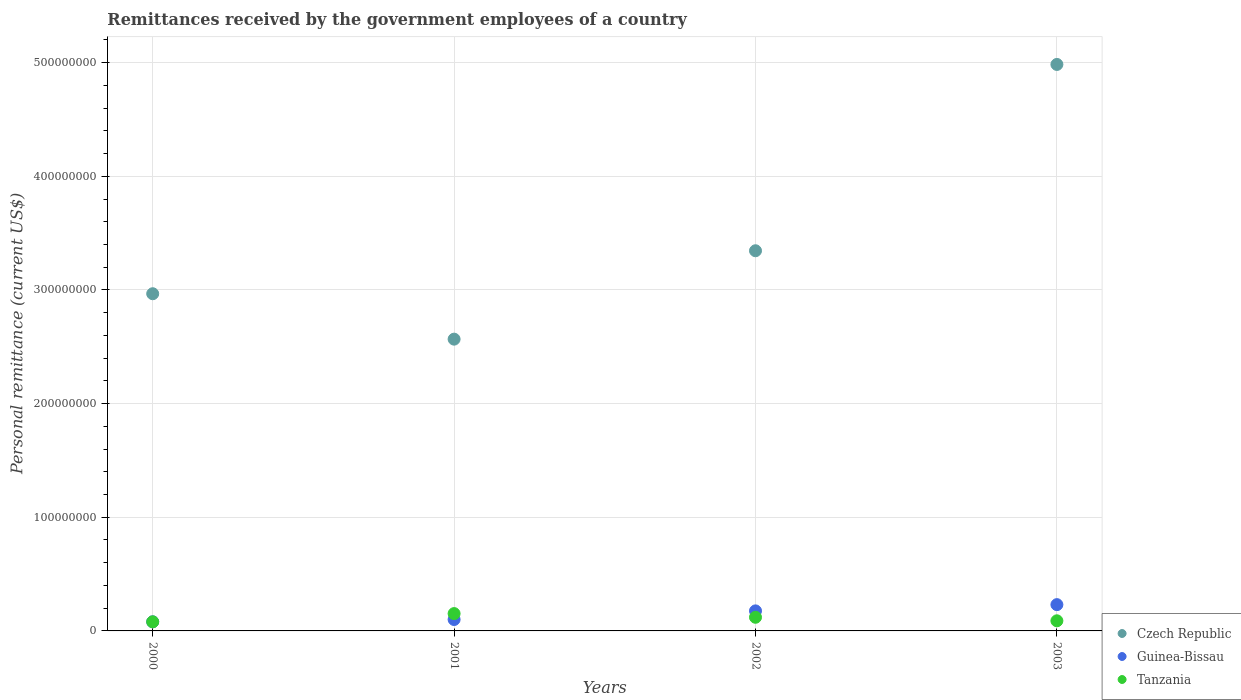How many different coloured dotlines are there?
Make the answer very short. 3. Is the number of dotlines equal to the number of legend labels?
Ensure brevity in your answer.  Yes. What is the remittances received by the government employees in Guinea-Bissau in 2003?
Your answer should be compact. 2.31e+07. Across all years, what is the maximum remittances received by the government employees in Guinea-Bissau?
Your answer should be compact. 2.31e+07. Across all years, what is the minimum remittances received by the government employees in Czech Republic?
Ensure brevity in your answer.  2.57e+08. What is the total remittances received by the government employees in Czech Republic in the graph?
Offer a terse response. 1.39e+09. What is the difference between the remittances received by the government employees in Czech Republic in 2000 and that in 2003?
Your response must be concise. -2.02e+08. What is the difference between the remittances received by the government employees in Czech Republic in 2003 and the remittances received by the government employees in Tanzania in 2001?
Provide a short and direct response. 4.83e+08. What is the average remittances received by the government employees in Czech Republic per year?
Your response must be concise. 3.47e+08. In the year 2003, what is the difference between the remittances received by the government employees in Tanzania and remittances received by the government employees in Czech Republic?
Your answer should be very brief. -4.90e+08. What is the ratio of the remittances received by the government employees in Czech Republic in 2000 to that in 2002?
Provide a short and direct response. 0.89. Is the remittances received by the government employees in Tanzania in 2000 less than that in 2001?
Give a very brief answer. Yes. What is the difference between the highest and the second highest remittances received by the government employees in Tanzania?
Provide a succinct answer. 3.25e+06. What is the difference between the highest and the lowest remittances received by the government employees in Tanzania?
Ensure brevity in your answer.  7.25e+06. In how many years, is the remittances received by the government employees in Guinea-Bissau greater than the average remittances received by the government employees in Guinea-Bissau taken over all years?
Offer a very short reply. 2. Is it the case that in every year, the sum of the remittances received by the government employees in Tanzania and remittances received by the government employees in Czech Republic  is greater than the remittances received by the government employees in Guinea-Bissau?
Provide a short and direct response. Yes. How many years are there in the graph?
Make the answer very short. 4. Are the values on the major ticks of Y-axis written in scientific E-notation?
Make the answer very short. No. What is the title of the graph?
Offer a very short reply. Remittances received by the government employees of a country. What is the label or title of the X-axis?
Your answer should be very brief. Years. What is the label or title of the Y-axis?
Your answer should be very brief. Personal remittance (current US$). What is the Personal remittance (current US$) in Czech Republic in 2000?
Give a very brief answer. 2.97e+08. What is the Personal remittance (current US$) in Guinea-Bissau in 2000?
Provide a short and direct response. 8.02e+06. What is the Personal remittance (current US$) in Tanzania in 2000?
Ensure brevity in your answer.  8.00e+06. What is the Personal remittance (current US$) of Czech Republic in 2001?
Your answer should be compact. 2.57e+08. What is the Personal remittance (current US$) in Guinea-Bissau in 2001?
Offer a terse response. 1.00e+07. What is the Personal remittance (current US$) in Tanzania in 2001?
Offer a very short reply. 1.53e+07. What is the Personal remittance (current US$) of Czech Republic in 2002?
Keep it short and to the point. 3.34e+08. What is the Personal remittance (current US$) of Guinea-Bissau in 2002?
Give a very brief answer. 1.76e+07. What is the Personal remittance (current US$) in Czech Republic in 2003?
Give a very brief answer. 4.98e+08. What is the Personal remittance (current US$) of Guinea-Bissau in 2003?
Provide a short and direct response. 2.31e+07. What is the Personal remittance (current US$) in Tanzania in 2003?
Your answer should be compact. 8.90e+06. Across all years, what is the maximum Personal remittance (current US$) of Czech Republic?
Your response must be concise. 4.98e+08. Across all years, what is the maximum Personal remittance (current US$) of Guinea-Bissau?
Your response must be concise. 2.31e+07. Across all years, what is the maximum Personal remittance (current US$) of Tanzania?
Offer a terse response. 1.53e+07. Across all years, what is the minimum Personal remittance (current US$) in Czech Republic?
Offer a terse response. 2.57e+08. Across all years, what is the minimum Personal remittance (current US$) in Guinea-Bissau?
Provide a short and direct response. 8.02e+06. Across all years, what is the minimum Personal remittance (current US$) of Tanzania?
Your answer should be compact. 8.00e+06. What is the total Personal remittance (current US$) in Czech Republic in the graph?
Give a very brief answer. 1.39e+09. What is the total Personal remittance (current US$) of Guinea-Bissau in the graph?
Offer a very short reply. 5.88e+07. What is the total Personal remittance (current US$) in Tanzania in the graph?
Make the answer very short. 4.42e+07. What is the difference between the Personal remittance (current US$) in Czech Republic in 2000 and that in 2001?
Provide a succinct answer. 4.00e+07. What is the difference between the Personal remittance (current US$) of Guinea-Bissau in 2000 and that in 2001?
Ensure brevity in your answer.  -2.01e+06. What is the difference between the Personal remittance (current US$) of Tanzania in 2000 and that in 2001?
Your answer should be very brief. -7.25e+06. What is the difference between the Personal remittance (current US$) of Czech Republic in 2000 and that in 2002?
Make the answer very short. -3.78e+07. What is the difference between the Personal remittance (current US$) in Guinea-Bissau in 2000 and that in 2002?
Keep it short and to the point. -9.61e+06. What is the difference between the Personal remittance (current US$) in Tanzania in 2000 and that in 2002?
Provide a short and direct response. -4.00e+06. What is the difference between the Personal remittance (current US$) of Czech Republic in 2000 and that in 2003?
Give a very brief answer. -2.02e+08. What is the difference between the Personal remittance (current US$) in Guinea-Bissau in 2000 and that in 2003?
Provide a short and direct response. -1.51e+07. What is the difference between the Personal remittance (current US$) in Tanzania in 2000 and that in 2003?
Provide a succinct answer. -9.00e+05. What is the difference between the Personal remittance (current US$) in Czech Republic in 2001 and that in 2002?
Provide a short and direct response. -7.78e+07. What is the difference between the Personal remittance (current US$) of Guinea-Bissau in 2001 and that in 2002?
Make the answer very short. -7.60e+06. What is the difference between the Personal remittance (current US$) of Tanzania in 2001 and that in 2002?
Your response must be concise. 3.25e+06. What is the difference between the Personal remittance (current US$) in Czech Republic in 2001 and that in 2003?
Make the answer very short. -2.42e+08. What is the difference between the Personal remittance (current US$) in Guinea-Bissau in 2001 and that in 2003?
Keep it short and to the point. -1.31e+07. What is the difference between the Personal remittance (current US$) in Tanzania in 2001 and that in 2003?
Keep it short and to the point. 6.35e+06. What is the difference between the Personal remittance (current US$) in Czech Republic in 2002 and that in 2003?
Offer a very short reply. -1.64e+08. What is the difference between the Personal remittance (current US$) in Guinea-Bissau in 2002 and that in 2003?
Offer a terse response. -5.49e+06. What is the difference between the Personal remittance (current US$) in Tanzania in 2002 and that in 2003?
Your answer should be compact. 3.10e+06. What is the difference between the Personal remittance (current US$) of Czech Republic in 2000 and the Personal remittance (current US$) of Guinea-Bissau in 2001?
Your answer should be compact. 2.87e+08. What is the difference between the Personal remittance (current US$) in Czech Republic in 2000 and the Personal remittance (current US$) in Tanzania in 2001?
Make the answer very short. 2.81e+08. What is the difference between the Personal remittance (current US$) in Guinea-Bissau in 2000 and the Personal remittance (current US$) in Tanzania in 2001?
Give a very brief answer. -7.23e+06. What is the difference between the Personal remittance (current US$) of Czech Republic in 2000 and the Personal remittance (current US$) of Guinea-Bissau in 2002?
Your response must be concise. 2.79e+08. What is the difference between the Personal remittance (current US$) of Czech Republic in 2000 and the Personal remittance (current US$) of Tanzania in 2002?
Offer a very short reply. 2.85e+08. What is the difference between the Personal remittance (current US$) in Guinea-Bissau in 2000 and the Personal remittance (current US$) in Tanzania in 2002?
Your answer should be compact. -3.98e+06. What is the difference between the Personal remittance (current US$) of Czech Republic in 2000 and the Personal remittance (current US$) of Guinea-Bissau in 2003?
Provide a short and direct response. 2.74e+08. What is the difference between the Personal remittance (current US$) of Czech Republic in 2000 and the Personal remittance (current US$) of Tanzania in 2003?
Offer a very short reply. 2.88e+08. What is the difference between the Personal remittance (current US$) in Guinea-Bissau in 2000 and the Personal remittance (current US$) in Tanzania in 2003?
Offer a very short reply. -8.79e+05. What is the difference between the Personal remittance (current US$) in Czech Republic in 2001 and the Personal remittance (current US$) in Guinea-Bissau in 2002?
Provide a short and direct response. 2.39e+08. What is the difference between the Personal remittance (current US$) of Czech Republic in 2001 and the Personal remittance (current US$) of Tanzania in 2002?
Make the answer very short. 2.45e+08. What is the difference between the Personal remittance (current US$) of Guinea-Bissau in 2001 and the Personal remittance (current US$) of Tanzania in 2002?
Provide a succinct answer. -1.97e+06. What is the difference between the Personal remittance (current US$) of Czech Republic in 2001 and the Personal remittance (current US$) of Guinea-Bissau in 2003?
Provide a succinct answer. 2.34e+08. What is the difference between the Personal remittance (current US$) in Czech Republic in 2001 and the Personal remittance (current US$) in Tanzania in 2003?
Ensure brevity in your answer.  2.48e+08. What is the difference between the Personal remittance (current US$) of Guinea-Bissau in 2001 and the Personal remittance (current US$) of Tanzania in 2003?
Provide a short and direct response. 1.13e+06. What is the difference between the Personal remittance (current US$) in Czech Republic in 2002 and the Personal remittance (current US$) in Guinea-Bissau in 2003?
Make the answer very short. 3.11e+08. What is the difference between the Personal remittance (current US$) in Czech Republic in 2002 and the Personal remittance (current US$) in Tanzania in 2003?
Your answer should be very brief. 3.26e+08. What is the difference between the Personal remittance (current US$) in Guinea-Bissau in 2002 and the Personal remittance (current US$) in Tanzania in 2003?
Offer a very short reply. 8.73e+06. What is the average Personal remittance (current US$) of Czech Republic per year?
Your answer should be compact. 3.47e+08. What is the average Personal remittance (current US$) in Guinea-Bissau per year?
Make the answer very short. 1.47e+07. What is the average Personal remittance (current US$) in Tanzania per year?
Your answer should be compact. 1.10e+07. In the year 2000, what is the difference between the Personal remittance (current US$) in Czech Republic and Personal remittance (current US$) in Guinea-Bissau?
Keep it short and to the point. 2.89e+08. In the year 2000, what is the difference between the Personal remittance (current US$) of Czech Republic and Personal remittance (current US$) of Tanzania?
Give a very brief answer. 2.89e+08. In the year 2000, what is the difference between the Personal remittance (current US$) in Guinea-Bissau and Personal remittance (current US$) in Tanzania?
Provide a succinct answer. 2.11e+04. In the year 2001, what is the difference between the Personal remittance (current US$) of Czech Republic and Personal remittance (current US$) of Guinea-Bissau?
Your answer should be very brief. 2.47e+08. In the year 2001, what is the difference between the Personal remittance (current US$) of Czech Republic and Personal remittance (current US$) of Tanzania?
Provide a short and direct response. 2.41e+08. In the year 2001, what is the difference between the Personal remittance (current US$) of Guinea-Bissau and Personal remittance (current US$) of Tanzania?
Offer a very short reply. -5.22e+06. In the year 2002, what is the difference between the Personal remittance (current US$) of Czech Republic and Personal remittance (current US$) of Guinea-Bissau?
Your response must be concise. 3.17e+08. In the year 2002, what is the difference between the Personal remittance (current US$) of Czech Republic and Personal remittance (current US$) of Tanzania?
Provide a short and direct response. 3.22e+08. In the year 2002, what is the difference between the Personal remittance (current US$) in Guinea-Bissau and Personal remittance (current US$) in Tanzania?
Offer a terse response. 5.63e+06. In the year 2003, what is the difference between the Personal remittance (current US$) in Czech Republic and Personal remittance (current US$) in Guinea-Bissau?
Make the answer very short. 4.75e+08. In the year 2003, what is the difference between the Personal remittance (current US$) in Czech Republic and Personal remittance (current US$) in Tanzania?
Give a very brief answer. 4.90e+08. In the year 2003, what is the difference between the Personal remittance (current US$) of Guinea-Bissau and Personal remittance (current US$) of Tanzania?
Provide a short and direct response. 1.42e+07. What is the ratio of the Personal remittance (current US$) in Czech Republic in 2000 to that in 2001?
Provide a short and direct response. 1.16. What is the ratio of the Personal remittance (current US$) of Guinea-Bissau in 2000 to that in 2001?
Offer a very short reply. 0.8. What is the ratio of the Personal remittance (current US$) of Tanzania in 2000 to that in 2001?
Offer a terse response. 0.52. What is the ratio of the Personal remittance (current US$) of Czech Republic in 2000 to that in 2002?
Give a very brief answer. 0.89. What is the ratio of the Personal remittance (current US$) of Guinea-Bissau in 2000 to that in 2002?
Your response must be concise. 0.45. What is the ratio of the Personal remittance (current US$) in Tanzania in 2000 to that in 2002?
Ensure brevity in your answer.  0.67. What is the ratio of the Personal remittance (current US$) of Czech Republic in 2000 to that in 2003?
Offer a terse response. 0.6. What is the ratio of the Personal remittance (current US$) of Guinea-Bissau in 2000 to that in 2003?
Ensure brevity in your answer.  0.35. What is the ratio of the Personal remittance (current US$) of Tanzania in 2000 to that in 2003?
Keep it short and to the point. 0.9. What is the ratio of the Personal remittance (current US$) of Czech Republic in 2001 to that in 2002?
Give a very brief answer. 0.77. What is the ratio of the Personal remittance (current US$) of Guinea-Bissau in 2001 to that in 2002?
Your answer should be compact. 0.57. What is the ratio of the Personal remittance (current US$) in Tanzania in 2001 to that in 2002?
Your answer should be compact. 1.27. What is the ratio of the Personal remittance (current US$) of Czech Republic in 2001 to that in 2003?
Offer a very short reply. 0.52. What is the ratio of the Personal remittance (current US$) in Guinea-Bissau in 2001 to that in 2003?
Ensure brevity in your answer.  0.43. What is the ratio of the Personal remittance (current US$) of Tanzania in 2001 to that in 2003?
Your response must be concise. 1.71. What is the ratio of the Personal remittance (current US$) of Czech Republic in 2002 to that in 2003?
Ensure brevity in your answer.  0.67. What is the ratio of the Personal remittance (current US$) of Guinea-Bissau in 2002 to that in 2003?
Your answer should be very brief. 0.76. What is the ratio of the Personal remittance (current US$) of Tanzania in 2002 to that in 2003?
Provide a succinct answer. 1.35. What is the difference between the highest and the second highest Personal remittance (current US$) of Czech Republic?
Provide a short and direct response. 1.64e+08. What is the difference between the highest and the second highest Personal remittance (current US$) of Guinea-Bissau?
Offer a terse response. 5.49e+06. What is the difference between the highest and the second highest Personal remittance (current US$) of Tanzania?
Offer a very short reply. 3.25e+06. What is the difference between the highest and the lowest Personal remittance (current US$) in Czech Republic?
Provide a short and direct response. 2.42e+08. What is the difference between the highest and the lowest Personal remittance (current US$) of Guinea-Bissau?
Your answer should be very brief. 1.51e+07. What is the difference between the highest and the lowest Personal remittance (current US$) in Tanzania?
Offer a terse response. 7.25e+06. 